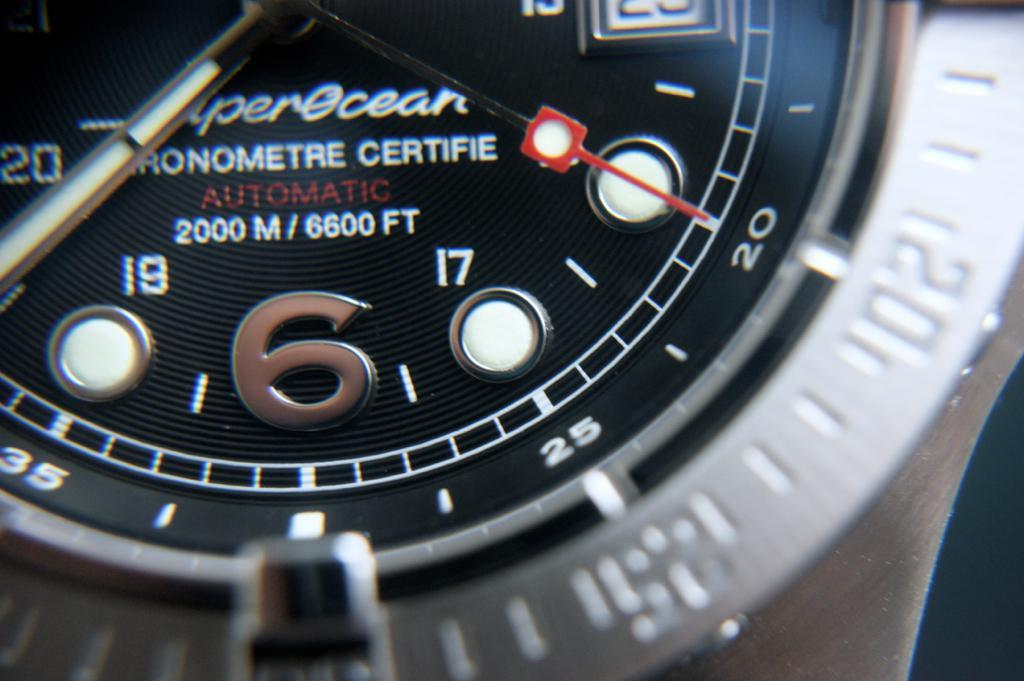<image>
Write a terse but informative summary of the picture. An automatic silver watch has a large number 6. 